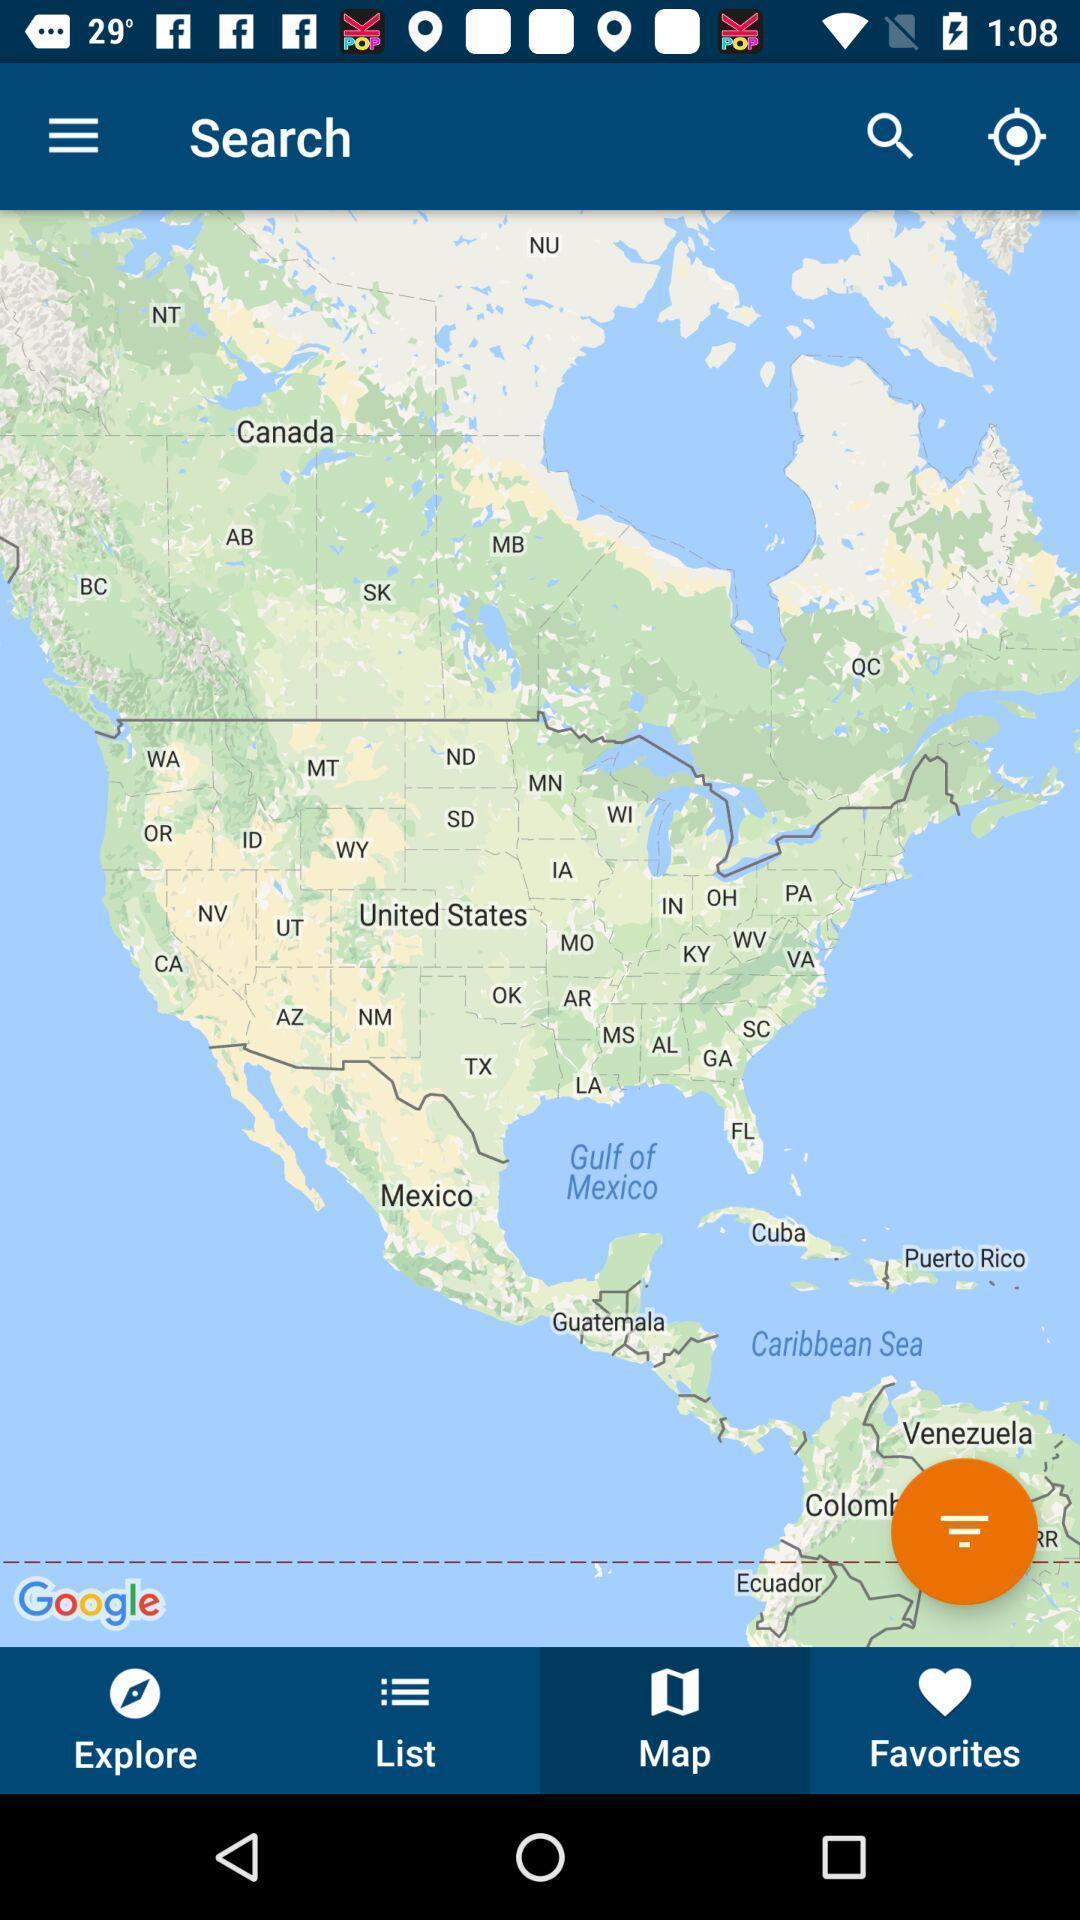Summarize the main components in this picture. Page shows about the navigation to find apartment. 